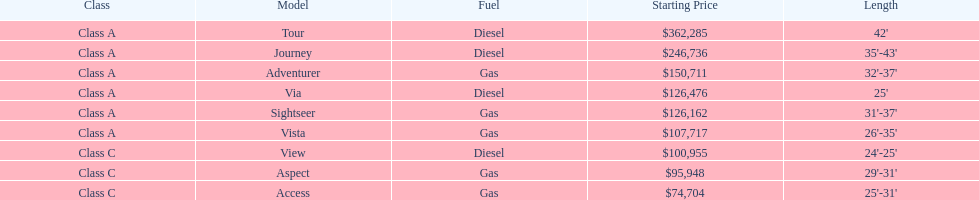Which model has the lowest started price? Access. 